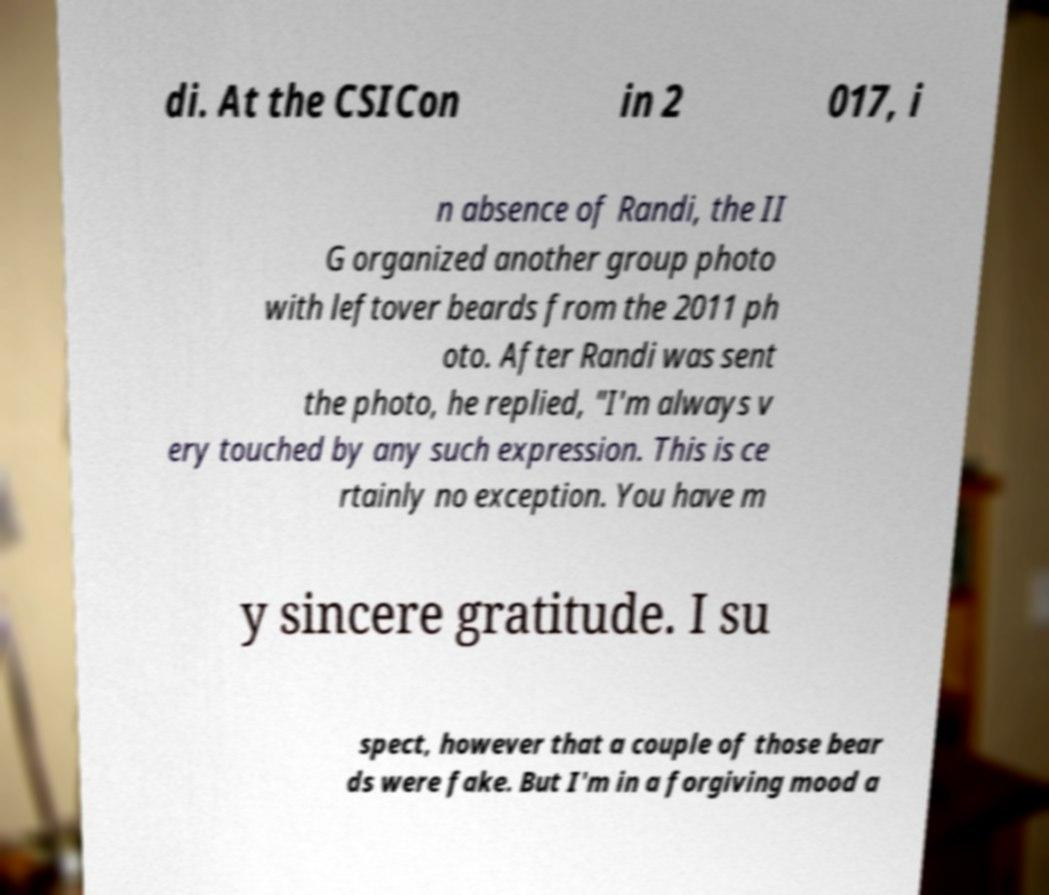Could you assist in decoding the text presented in this image and type it out clearly? di. At the CSICon in 2 017, i n absence of Randi, the II G organized another group photo with leftover beards from the 2011 ph oto. After Randi was sent the photo, he replied, "I'm always v ery touched by any such expression. This is ce rtainly no exception. You have m y sincere gratitude. I su spect, however that a couple of those bear ds were fake. But I'm in a forgiving mood a 